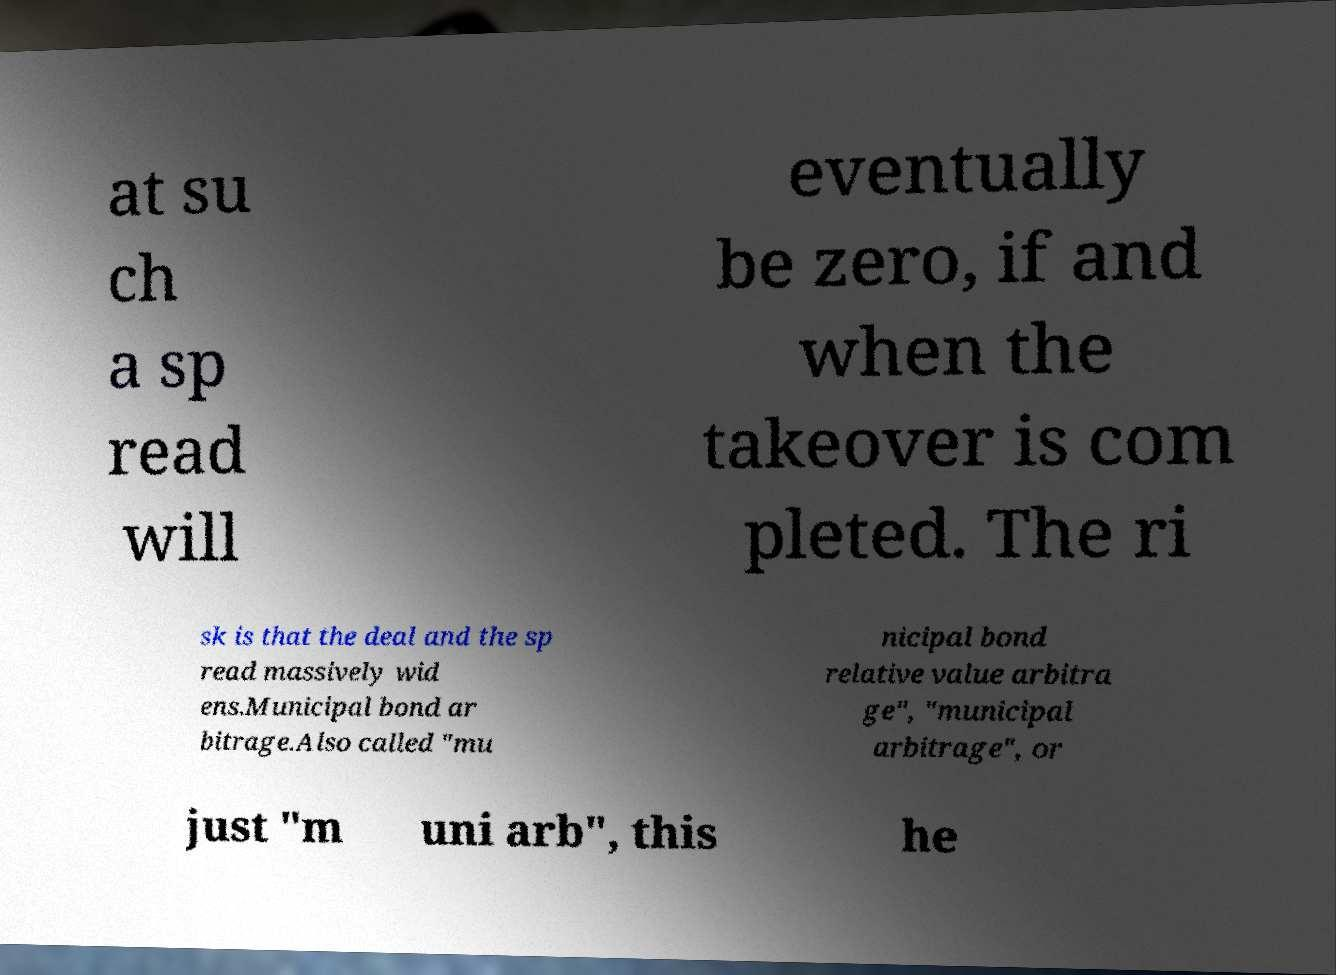There's text embedded in this image that I need extracted. Can you transcribe it verbatim? at su ch a sp read will eventually be zero, if and when the takeover is com pleted. The ri sk is that the deal and the sp read massively wid ens.Municipal bond ar bitrage.Also called "mu nicipal bond relative value arbitra ge", "municipal arbitrage", or just "m uni arb", this he 